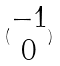<formula> <loc_0><loc_0><loc_500><loc_500>( \begin{matrix} - 1 \\ 0 \end{matrix} )</formula> 